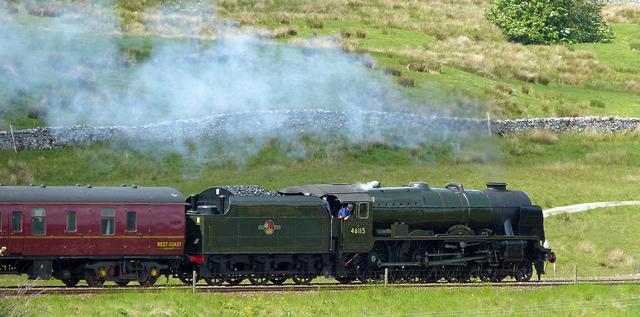Is there a brick wall next to the railway tracks?
Keep it brief. Yes. Can you see smoke coming from the train?
Answer briefly. Yes. How many cars of the train can you see?
Concise answer only. 3. 